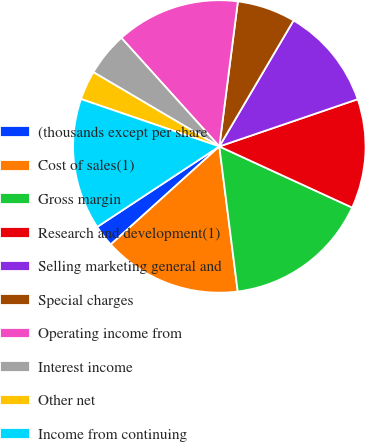Convert chart to OTSL. <chart><loc_0><loc_0><loc_500><loc_500><pie_chart><fcel>(thousands except per share<fcel>Cost of sales(1)<fcel>Gross margin<fcel>Research and development(1)<fcel>Selling marketing general and<fcel>Special charges<fcel>Operating income from<fcel>Interest income<fcel>Other net<fcel>Income from continuing<nl><fcel>2.42%<fcel>15.32%<fcel>16.13%<fcel>12.1%<fcel>11.29%<fcel>6.45%<fcel>13.71%<fcel>4.84%<fcel>3.23%<fcel>14.52%<nl></chart> 